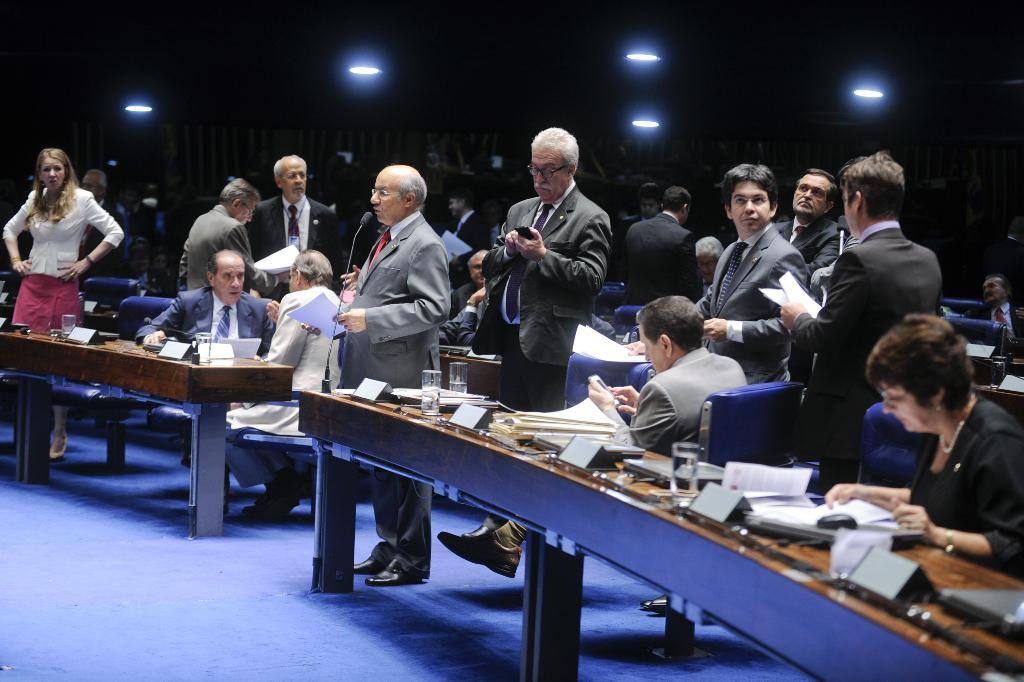What are the people in the image doing? There are persons sitting and standing in the image. What is on the table in the image? There is a glass, papers, and other things on the table. Can you describe the table in the image? There is a table in the image. What is visible at the top of the image? There are lights visible at the top of the image. What type of rhythm can be heard coming from the edge in the image? There is no reference to a rhythm or edge in the image, so it's not possible to determine what, if any, rhythm might be heard. 